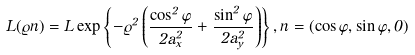Convert formula to latex. <formula><loc_0><loc_0><loc_500><loc_500>L ( \varrho { n } ) = L \exp \left \{ - \varrho ^ { 2 } \left ( \frac { \cos ^ { 2 } \varphi } { 2 a _ { x } ^ { 2 } } + \frac { \sin ^ { 2 } \varphi } { 2 a _ { y } ^ { 2 } } \right ) \right \} , { n } = ( \cos \varphi , \sin \varphi , 0 )</formula> 